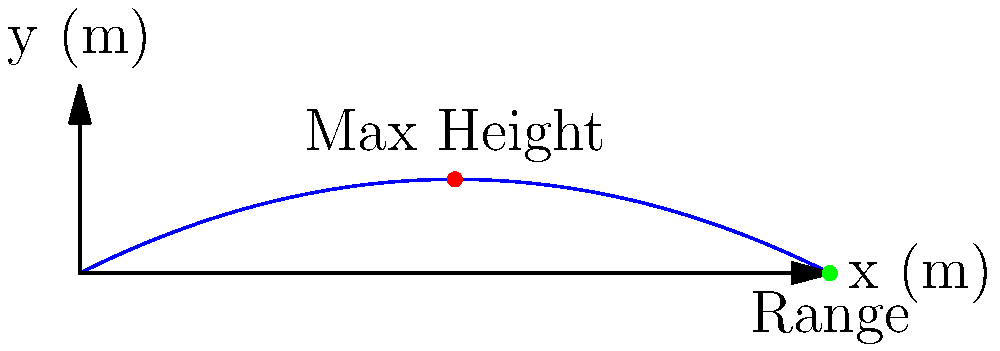In the animated movie "Brave," Merida uses her archery skills to launch projectiles. Imagine a similar scenario where a projectile is launched from a catapult, following a parabolic path as shown in the graph. If the maximum height of the projectile is 2.5 meters and it reaches the ground 20 meters away from the launch point, what is the initial velocity of the projectile? Assume the launch angle is 45° and neglect air resistance. (Use $g = 9.8 \text{ m/s}^2$) Let's approach this step-by-step:

1) For a projectile launched at 45°, the range (R) is given by:
   $R = \frac{v_0^2}{g}$, where $v_0$ is the initial velocity.

2) We know the range is 20 meters, so:
   $20 = \frac{v_0^2}{9.8}$

3) Solving for $v_0$:
   $v_0^2 = 20 \times 9.8 = 196$
   $v_0 = \sqrt{196} = 14 \text{ m/s}$

4) We can verify this using the maximum height formula:
   $h_{max} = \frac{v_0^2 \sin^2 \theta}{2g}$

5) Substituting our values:
   $2.5 = \frac{14^2 \times \sin^2 45°}{2 \times 9.8}$
   $2.5 = \frac{196 \times 0.5}{19.6} = 5$

6) This confirms our calculation, as the maximum height matches the given value.
Answer: 14 m/s 